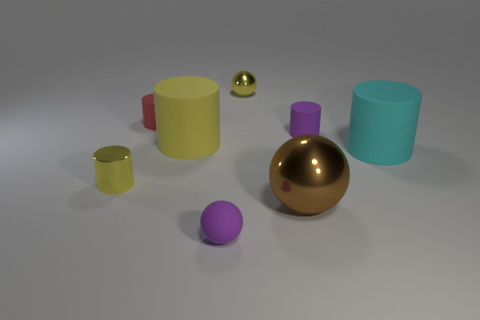There is another ball that is the same size as the yellow sphere; what is it made of?
Offer a terse response. Rubber. Is there a cyan object that has the same size as the yellow rubber cylinder?
Provide a short and direct response. Yes. Is the color of the sphere behind the large yellow matte cylinder the same as the big matte thing that is to the left of the small purple ball?
Your answer should be very brief. Yes. What number of shiny objects are either large brown things or small yellow cylinders?
Offer a very short reply. 2. What number of rubber things are in front of the small matte object behind the tiny thing right of the large brown metallic sphere?
Provide a succinct answer. 4. There is a sphere that is made of the same material as the small red cylinder; what size is it?
Your answer should be compact. Small. How many rubber cylinders are the same color as the small metallic sphere?
Make the answer very short. 1. Do the yellow metal object that is in front of the red matte cylinder and the big cyan matte cylinder have the same size?
Offer a terse response. No. There is a small rubber object that is behind the brown object and left of the large brown sphere; what is its color?
Provide a succinct answer. Red. What number of objects are brown metal objects or red objects that are behind the tiny rubber sphere?
Your answer should be very brief. 2. 